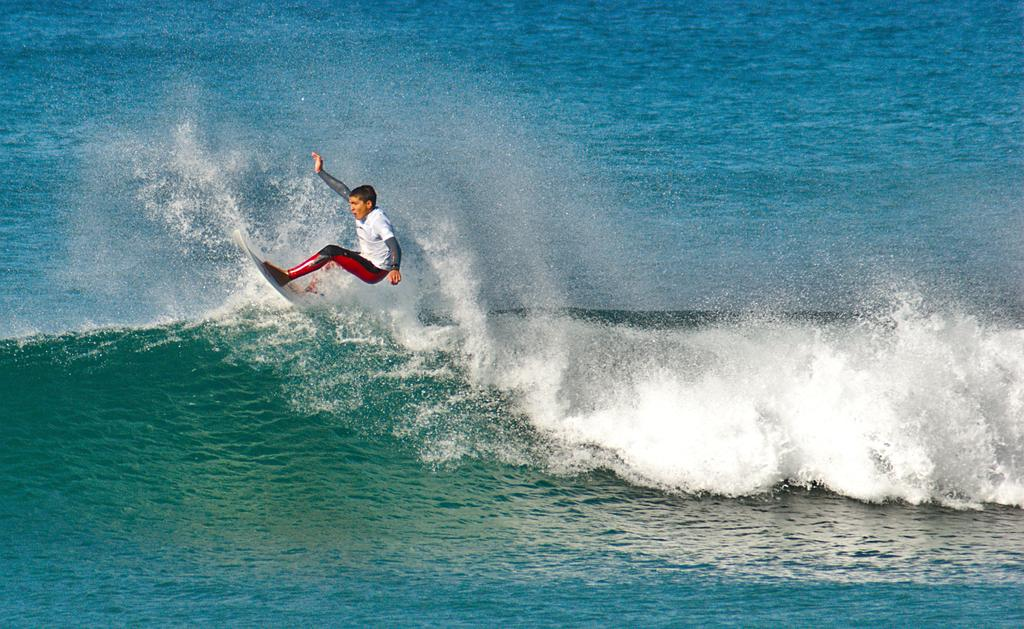What is the main subject of the image? There is a person in the image. What activity is the person engaged in? The person is surfing on the water. What type of kitty can be seen reading prose on a card in the image? There is no kitty, prose, or card present in the image; it features a person surfing on the water. 